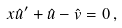Convert formula to latex. <formula><loc_0><loc_0><loc_500><loc_500>x \hat { u } ^ { \prime } + \hat { u } - \hat { v } = 0 \, ,</formula> 